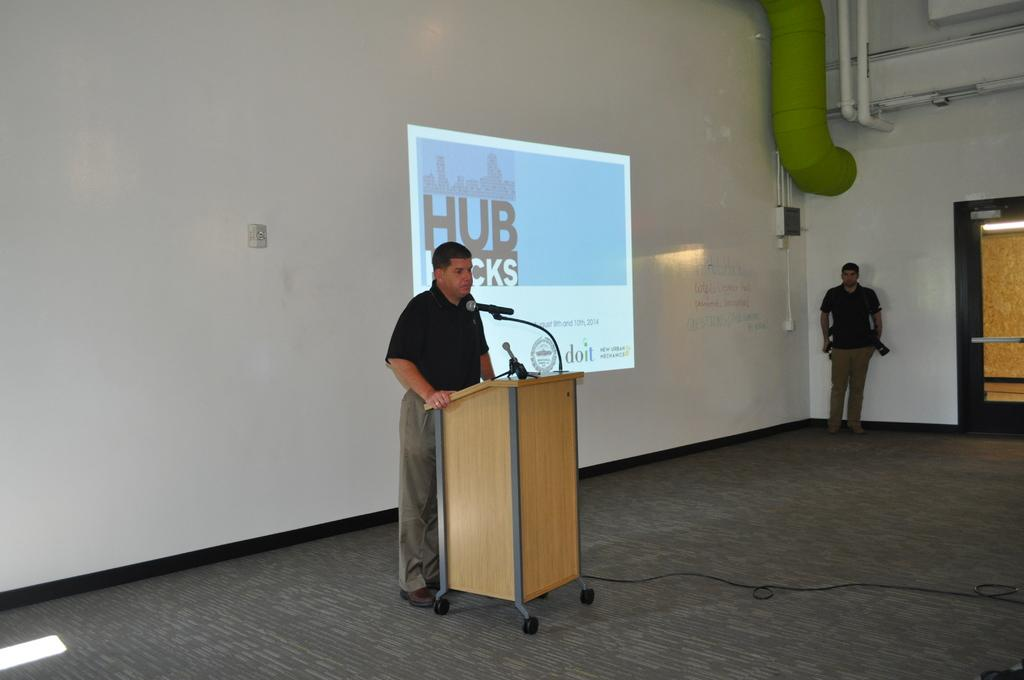What is the color of the wall in the image? The wall in the image is white. What can be seen on the wall in the image? There is a screen on the wall in the image. What other object is present in the image? There is a door in the image. What device is visible in the image? There is a mic in the image. How many people are in the image? Two persons are present in the image. What are the two persons wearing? The two persons are wearing black color t-shirts. What type of produce is being grown in the middle of the image? There is no produce or garden present in the image; it features a wall, screen, door, mic, and two persons wearing black t-shirts. How can you tell that the two persons are feeling angry in the image? There is no indication of emotions or expressions in the image, so it cannot be determined if the two persons are feeling angry or any other emotion. 